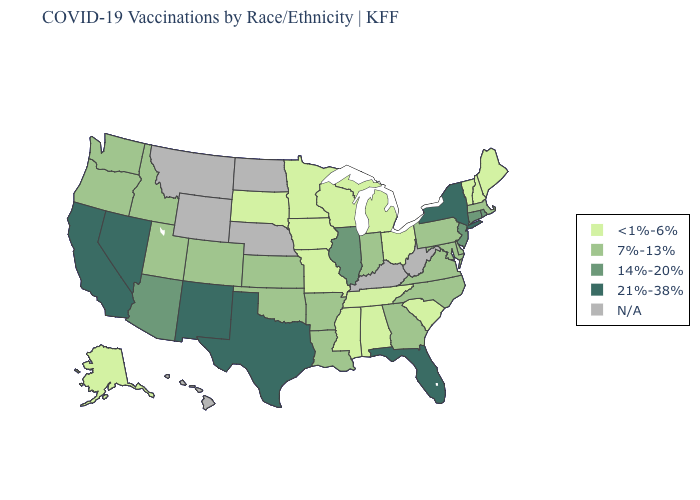Does Rhode Island have the highest value in the Northeast?
Quick response, please. No. What is the value of Indiana?
Quick response, please. 7%-13%. Name the states that have a value in the range 21%-38%?
Keep it brief. California, Florida, Nevada, New Mexico, New York, Texas. Does Arizona have the highest value in the USA?
Write a very short answer. No. What is the highest value in states that border Kentucky?
Give a very brief answer. 14%-20%. Name the states that have a value in the range N/A?
Give a very brief answer. Hawaii, Kentucky, Montana, Nebraska, North Dakota, West Virginia, Wyoming. What is the value of North Carolina?
Short answer required. 7%-13%. Which states have the lowest value in the USA?
Write a very short answer. Alabama, Alaska, Iowa, Maine, Michigan, Minnesota, Mississippi, Missouri, New Hampshire, Ohio, South Carolina, South Dakota, Tennessee, Vermont, Wisconsin. Name the states that have a value in the range <1%-6%?
Give a very brief answer. Alabama, Alaska, Iowa, Maine, Michigan, Minnesota, Mississippi, Missouri, New Hampshire, Ohio, South Carolina, South Dakota, Tennessee, Vermont, Wisconsin. Does the map have missing data?
Concise answer only. Yes. Name the states that have a value in the range <1%-6%?
Keep it brief. Alabama, Alaska, Iowa, Maine, Michigan, Minnesota, Mississippi, Missouri, New Hampshire, Ohio, South Carolina, South Dakota, Tennessee, Vermont, Wisconsin. Among the states that border Massachusetts , does New York have the highest value?
Be succinct. Yes. 